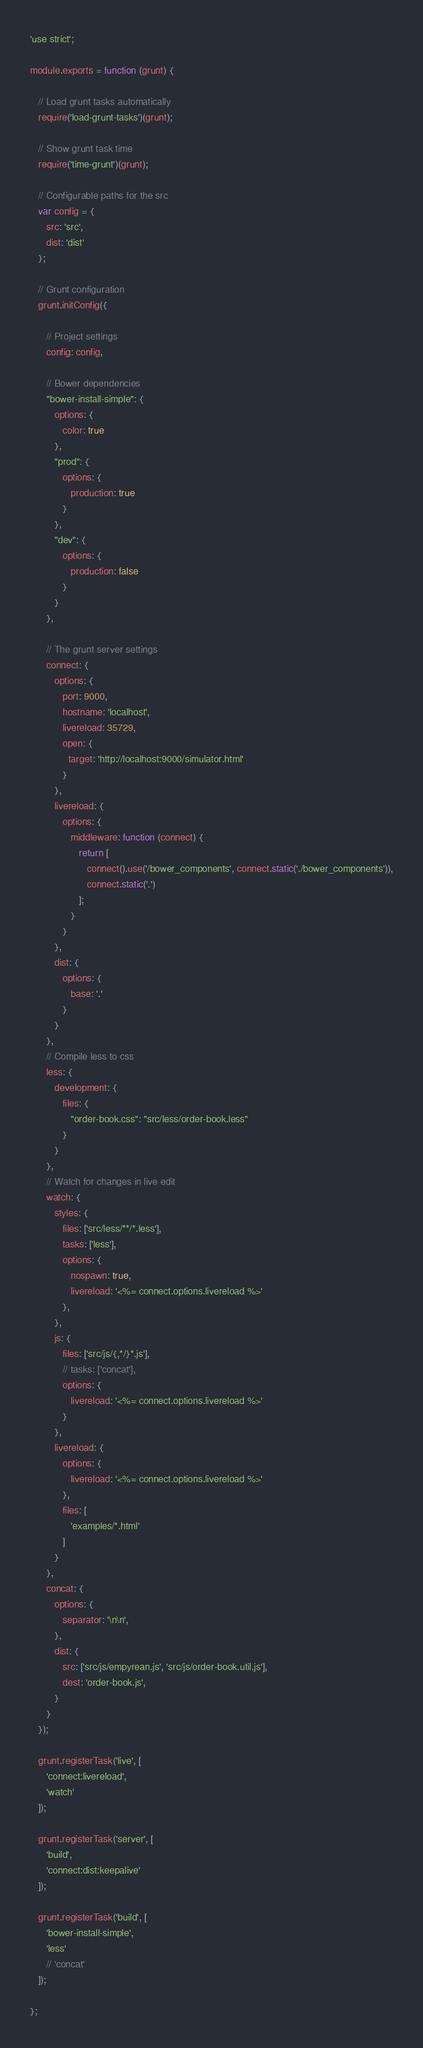Convert code to text. <code><loc_0><loc_0><loc_500><loc_500><_JavaScript_>'use strict';

module.exports = function (grunt) {

   // Load grunt tasks automatically
   require('load-grunt-tasks')(grunt);

   // Show grunt task time
   require('time-grunt')(grunt);

   // Configurable paths for the src
   var config = {
      src: 'src',
      dist: 'dist'
   };

   // Grunt configuration
   grunt.initConfig({

      // Project settings
      config: config,

      // Bower dependencies
      "bower-install-simple": {
         options: {
            color: true
         },
         "prod": {
            options: {
               production: true
            }
         },
         "dev": {
            options: {
               production: false
            }
         }
      },

      // The grunt server settings
      connect: {
         options: {
            port: 9000,
            hostname: 'localhost',
            livereload: 35729,
            open: {
              target: 'http://localhost:9000/simulator.html'
            }
         },
         livereload: {
            options: {
               middleware: function (connect) {
                  return [
                     connect().use('/bower_components', connect.static('./bower_components')),
                     connect.static('.')
                  ];
               }
            }
         },
         dist: {
            options: {
               base: '.'
            }
         }
      },
      // Compile less to css
      less: {
         development: {
            files: {
               "order-book.css": "src/less/order-book.less"
            }
         }
      },
      // Watch for changes in live edit
      watch: {
         styles: {
            files: ['src/less/**/*.less'],
            tasks: ['less'],
            options: {
               nospawn: true,
               livereload: '<%= connect.options.livereload %>'
            },
         },
         js: {
            files: ['src/js/{,*/}*.js'],
            // tasks: ['concat'],
            options: {
               livereload: '<%= connect.options.livereload %>'
            }
         },
         livereload: {
            options: {
               livereload: '<%= connect.options.livereload %>'
            },
            files: [
               'examples/*.html'
            ]
         }
      },
      concat: {
         options: {
            separator: '\n\n',
         },
         dist: {
            src: ['src/js/empyrean.js', 'src/js/order-book.util.js'],
            dest: 'order-book.js',
         }
      }
   });

   grunt.registerTask('live', [
      'connect:livereload',
      'watch'
   ]);

   grunt.registerTask('server', [
      'build',
      'connect:dist:keepalive'
   ]);

   grunt.registerTask('build', [
      'bower-install-simple',
      'less'
      // 'concat'
   ]);

};
</code> 